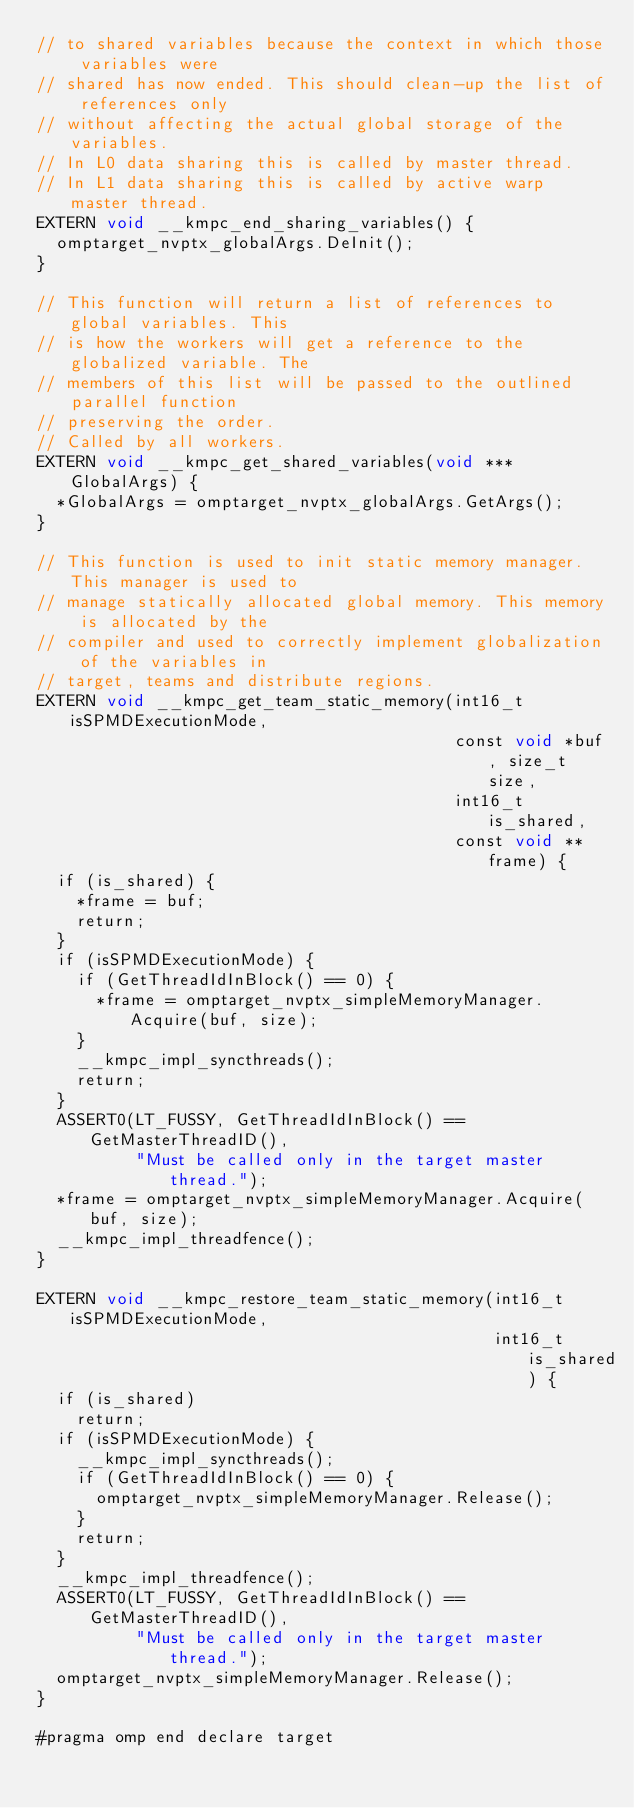Convert code to text. <code><loc_0><loc_0><loc_500><loc_500><_Cuda_>// to shared variables because the context in which those variables were
// shared has now ended. This should clean-up the list of references only
// without affecting the actual global storage of the variables.
// In L0 data sharing this is called by master thread.
// In L1 data sharing this is called by active warp master thread.
EXTERN void __kmpc_end_sharing_variables() {
  omptarget_nvptx_globalArgs.DeInit();
}

// This function will return a list of references to global variables. This
// is how the workers will get a reference to the globalized variable. The
// members of this list will be passed to the outlined parallel function
// preserving the order.
// Called by all workers.
EXTERN void __kmpc_get_shared_variables(void ***GlobalArgs) {
  *GlobalArgs = omptarget_nvptx_globalArgs.GetArgs();
}

// This function is used to init static memory manager. This manager is used to
// manage statically allocated global memory. This memory is allocated by the
// compiler and used to correctly implement globalization of the variables in
// target, teams and distribute regions.
EXTERN void __kmpc_get_team_static_memory(int16_t isSPMDExecutionMode,
                                          const void *buf, size_t size,
                                          int16_t is_shared,
                                          const void **frame) {
  if (is_shared) {
    *frame = buf;
    return;
  }
  if (isSPMDExecutionMode) {
    if (GetThreadIdInBlock() == 0) {
      *frame = omptarget_nvptx_simpleMemoryManager.Acquire(buf, size);
    }
    __kmpc_impl_syncthreads();
    return;
  }
  ASSERT0(LT_FUSSY, GetThreadIdInBlock() == GetMasterThreadID(),
          "Must be called only in the target master thread.");
  *frame = omptarget_nvptx_simpleMemoryManager.Acquire(buf, size);
  __kmpc_impl_threadfence();
}

EXTERN void __kmpc_restore_team_static_memory(int16_t isSPMDExecutionMode,
                                              int16_t is_shared) {
  if (is_shared)
    return;
  if (isSPMDExecutionMode) {
    __kmpc_impl_syncthreads();
    if (GetThreadIdInBlock() == 0) {
      omptarget_nvptx_simpleMemoryManager.Release();
    }
    return;
  }
  __kmpc_impl_threadfence();
  ASSERT0(LT_FUSSY, GetThreadIdInBlock() == GetMasterThreadID(),
          "Must be called only in the target master thread.");
  omptarget_nvptx_simpleMemoryManager.Release();
}

#pragma omp end declare target
</code> 